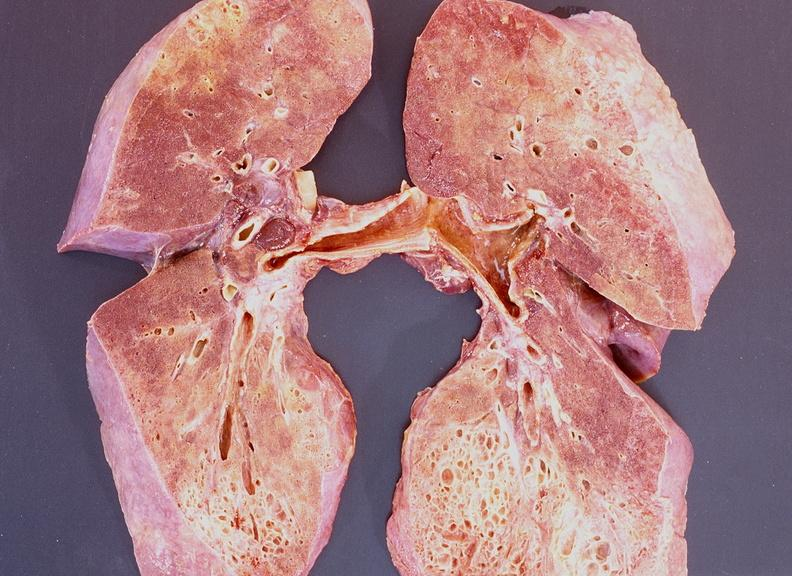does this image show lung fibrosis, scleroderma?
Answer the question using a single word or phrase. Yes 